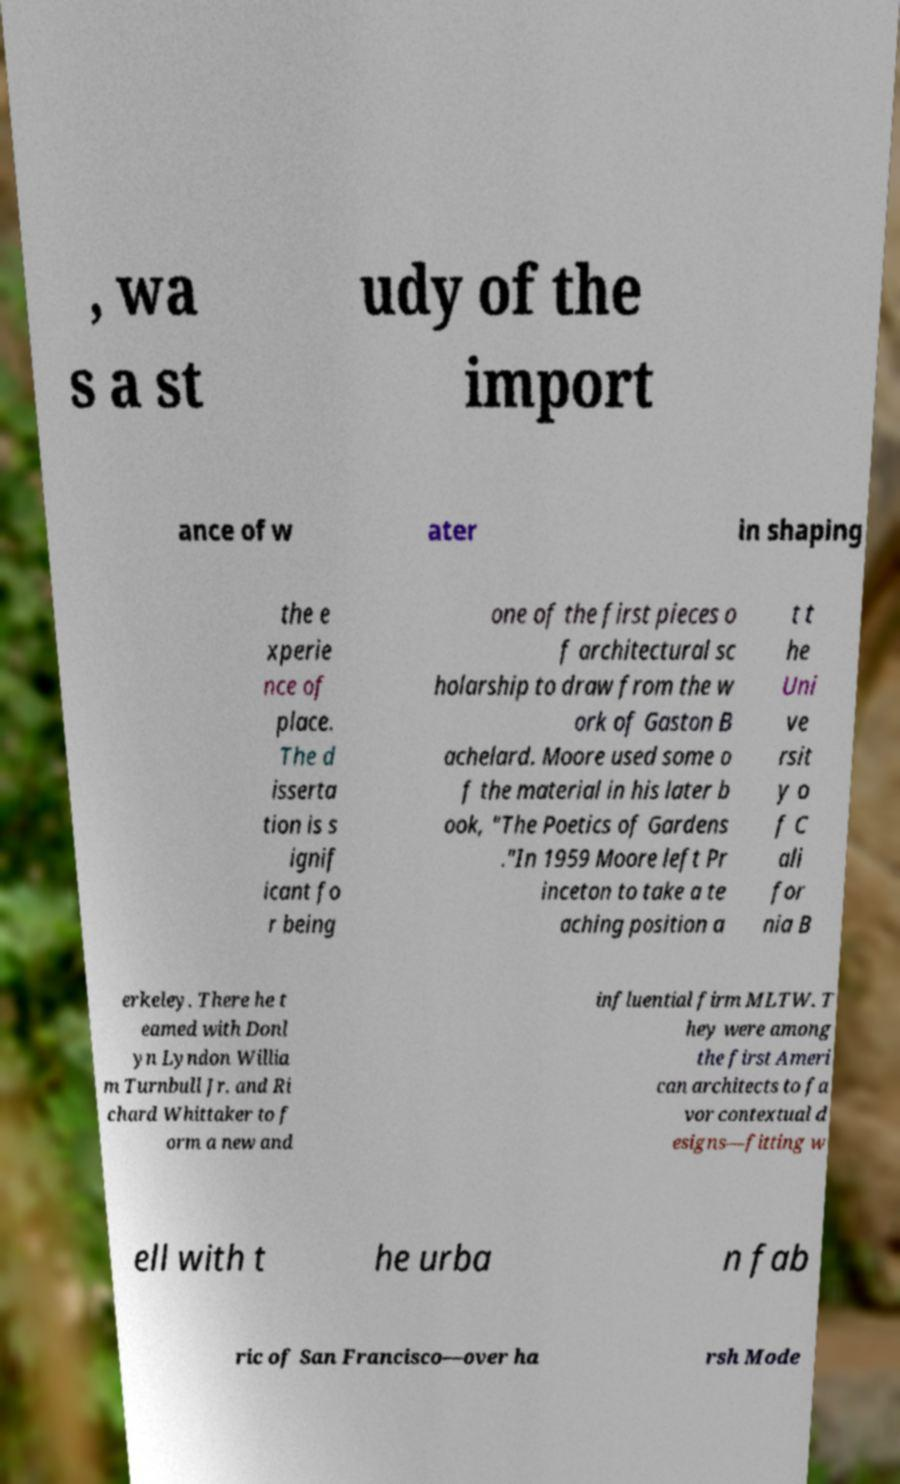Can you read and provide the text displayed in the image?This photo seems to have some interesting text. Can you extract and type it out for me? , wa s a st udy of the import ance of w ater in shaping the e xperie nce of place. The d isserta tion is s ignif icant fo r being one of the first pieces o f architectural sc holarship to draw from the w ork of Gaston B achelard. Moore used some o f the material in his later b ook, "The Poetics of Gardens ."In 1959 Moore left Pr inceton to take a te aching position a t t he Uni ve rsit y o f C ali for nia B erkeley. There he t eamed with Donl yn Lyndon Willia m Turnbull Jr. and Ri chard Whittaker to f orm a new and influential firm MLTW. T hey were among the first Ameri can architects to fa vor contextual d esigns—fitting w ell with t he urba n fab ric of San Francisco—over ha rsh Mode 